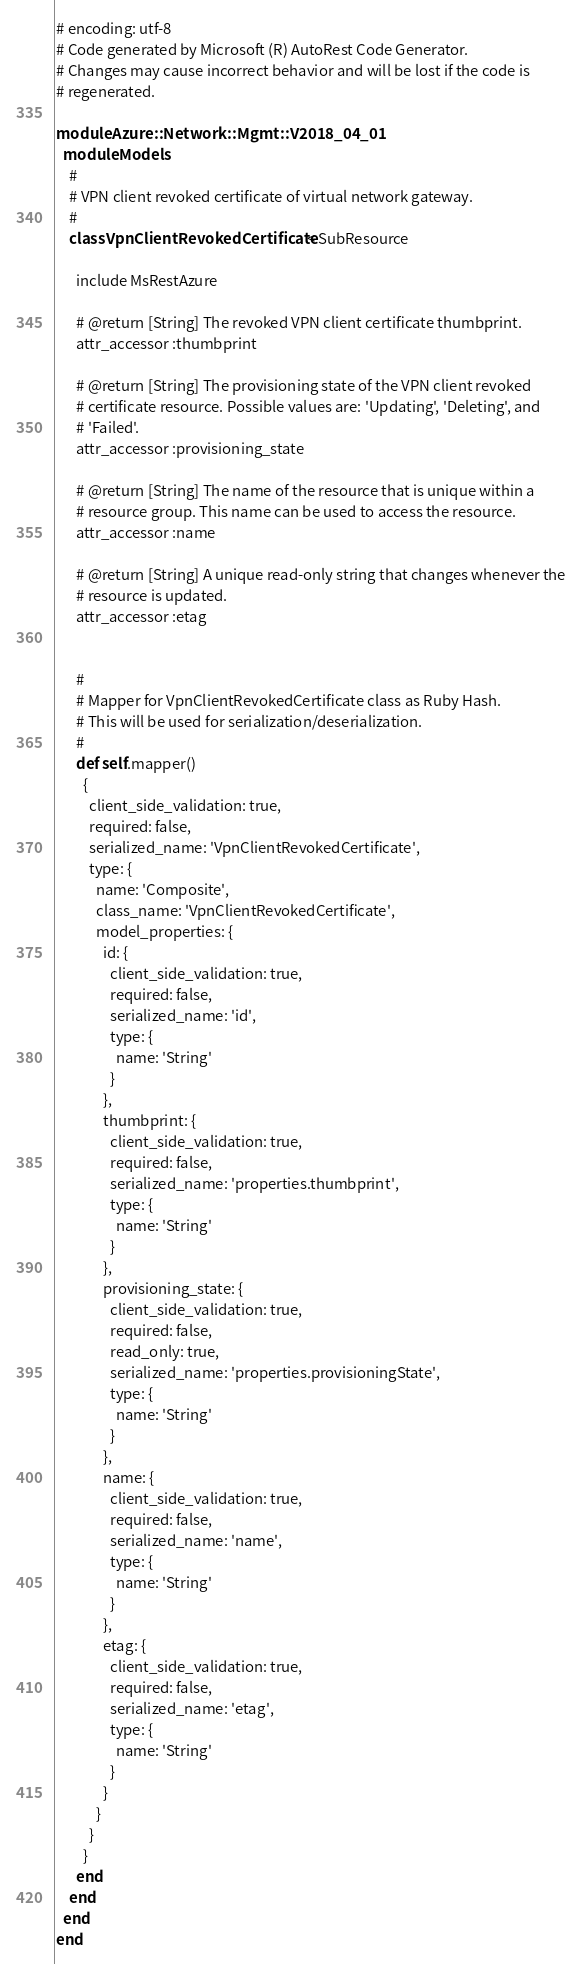<code> <loc_0><loc_0><loc_500><loc_500><_Ruby_># encoding: utf-8
# Code generated by Microsoft (R) AutoRest Code Generator.
# Changes may cause incorrect behavior and will be lost if the code is
# regenerated.

module Azure::Network::Mgmt::V2018_04_01
  module Models
    #
    # VPN client revoked certificate of virtual network gateway.
    #
    class VpnClientRevokedCertificate < SubResource

      include MsRestAzure

      # @return [String] The revoked VPN client certificate thumbprint.
      attr_accessor :thumbprint

      # @return [String] The provisioning state of the VPN client revoked
      # certificate resource. Possible values are: 'Updating', 'Deleting', and
      # 'Failed'.
      attr_accessor :provisioning_state

      # @return [String] The name of the resource that is unique within a
      # resource group. This name can be used to access the resource.
      attr_accessor :name

      # @return [String] A unique read-only string that changes whenever the
      # resource is updated.
      attr_accessor :etag


      #
      # Mapper for VpnClientRevokedCertificate class as Ruby Hash.
      # This will be used for serialization/deserialization.
      #
      def self.mapper()
        {
          client_side_validation: true,
          required: false,
          serialized_name: 'VpnClientRevokedCertificate',
          type: {
            name: 'Composite',
            class_name: 'VpnClientRevokedCertificate',
            model_properties: {
              id: {
                client_side_validation: true,
                required: false,
                serialized_name: 'id',
                type: {
                  name: 'String'
                }
              },
              thumbprint: {
                client_side_validation: true,
                required: false,
                serialized_name: 'properties.thumbprint',
                type: {
                  name: 'String'
                }
              },
              provisioning_state: {
                client_side_validation: true,
                required: false,
                read_only: true,
                serialized_name: 'properties.provisioningState',
                type: {
                  name: 'String'
                }
              },
              name: {
                client_side_validation: true,
                required: false,
                serialized_name: 'name',
                type: {
                  name: 'String'
                }
              },
              etag: {
                client_side_validation: true,
                required: false,
                serialized_name: 'etag',
                type: {
                  name: 'String'
                }
              }
            }
          }
        }
      end
    end
  end
end
</code> 